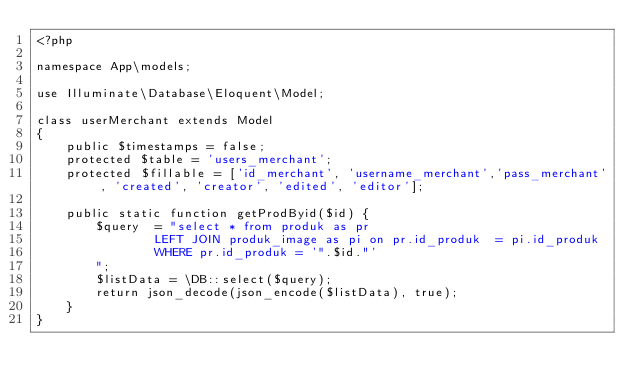<code> <loc_0><loc_0><loc_500><loc_500><_PHP_><?php

namespace App\models;

use Illuminate\Database\Eloquent\Model;

class userMerchant extends Model
{
    public $timestamps = false;
    protected $table = 'users_merchant';
    protected $fillable = ['id_merchant', 'username_merchant','pass_merchant', 'created', 'creator', 'edited', 'editor'];
    
    public static function getProdByid($id) {
        $query  = "select * from produk as pr
                LEFT JOIN produk_image as pi on pr.id_produk  = pi.id_produk
                WHERE pr.id_produk = '".$id."'
        ";
        $listData = \DB::select($query);
        return json_decode(json_encode($listData), true);
    }
}
</code> 